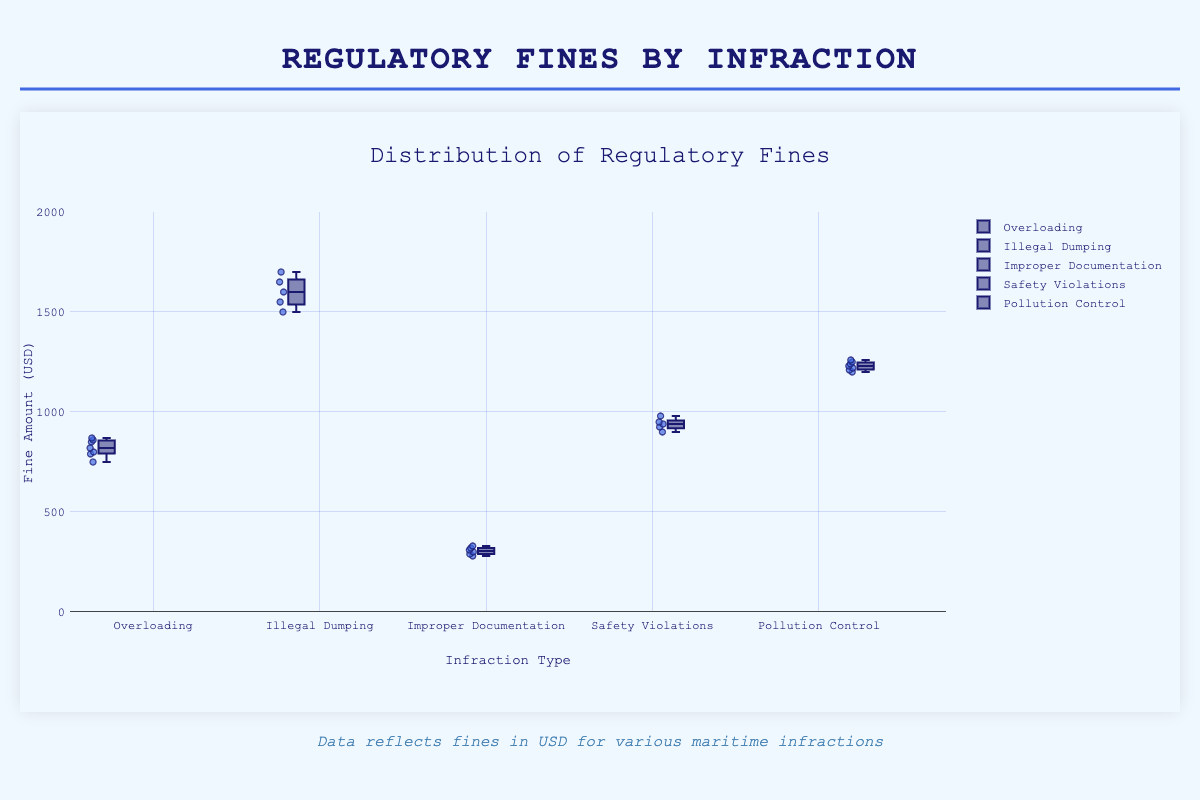What is the title of the plot? The title of the plot is located at the top and reads, "Distribution of Regulatory Fines."
Answer: Distribution of Regulatory Fines Which infraction has the highest median fine? The median fine of each box plot can be observed by the line inside the box. The "Illegal Dumping" infraction has the highest median fine.
Answer: Illegal Dumping How many data points are there for the "Overloading" infraction? The number of points can be counted from the individual points shown on the box plot for "Overloading," which are seven.
Answer: 7 What's the range of fines for "Improper Documentation"? The range is calculated by subtracting the minimum value from the maximum value within the box plot whiskers. For "Improper Documentation," the range is 330 - 280 = 50 USD.
Answer: 50 How does the median fine of "Safety Violations" compare to "Pollution Control"? The median fine for "Safety Violations" is around 940 USD, whereas the median for "Pollution Control" is around 1230 USD. "Pollution Control" has a higher median fine.
Answer: Pollution Control has a higher median fine Which infraction has the smallest interquartile range (IQR)? The IQR is the difference between the upper quartile (75th percentile) and the lower quartile (25th percentile) of the box plot. "Improper Documentation" has the smallest IQR.
Answer: Improper Documentation Is there any overlap in the fine amounts between “Illegal Dumping” and “Pollution Control”? Overlap can be checked if the whiskers of the box plots intersect. Both fines for "Pollution Control" range from 1210 to 1260 USD and "Illegal Dumping" range from 1500 to 1700 USD. Since neither range intersects, there is no overlap.
Answer: No overlap Which infraction shows the highest variability in fines? Variability can be measured by the range of the entire box plot, including whiskers. "Illegal Dumping" has the widest spread (1500 to 1700 USD).
Answer: Illegal Dumping What is the upper whisker value of the "Overloading" infraction? The upper whisker value is located at the topmost part of the "Overloading" box plot whisker, which is the highest data point, 870 USD.
Answer: 870 What are the mean fines for "Illegal Dumping" and "Safety Violations"? Calculate the mean by summing the data points and dividing by the number of points. Illegal Dumping: (1500 + 1700 + 1600 + 1550 + 1650) / 5 = 1600 USD. Safety Violations: (950 + 900 + 925 + 940 + 980) / 5 = 939 USD.
Answer: Illegal Dumping: 1600, Safety Violations: 939 